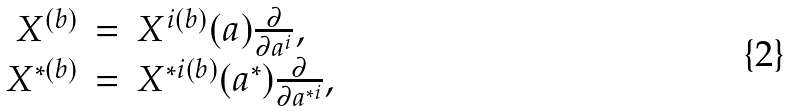<formula> <loc_0><loc_0><loc_500><loc_500>\begin{array} { r c l } X ^ { ( b ) } & = & X ^ { i ( b ) } ( a ) \frac { \partial } { \partial a ^ { i } } , \\ X ^ { * ( b ) } & = & X ^ { * i ( b ) } ( a ^ { * } ) \frac { \partial } { \partial a ^ { * i } } , \end{array}</formula> 